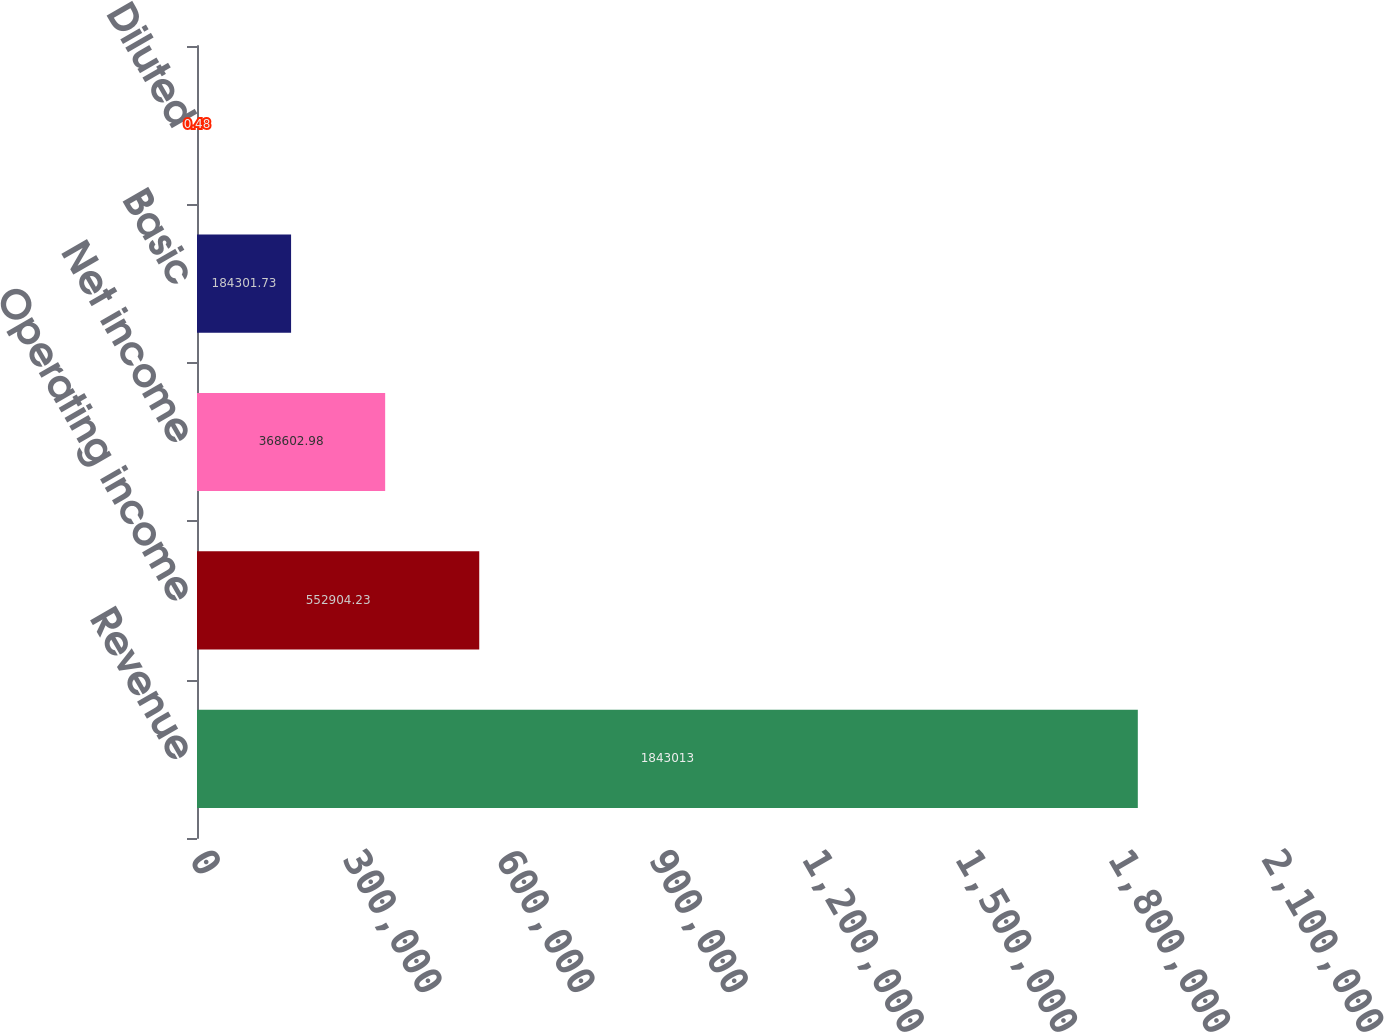Convert chart. <chart><loc_0><loc_0><loc_500><loc_500><bar_chart><fcel>Revenue<fcel>Operating income<fcel>Net income<fcel>Basic<fcel>Diluted<nl><fcel>1.84301e+06<fcel>552904<fcel>368603<fcel>184302<fcel>0.48<nl></chart> 